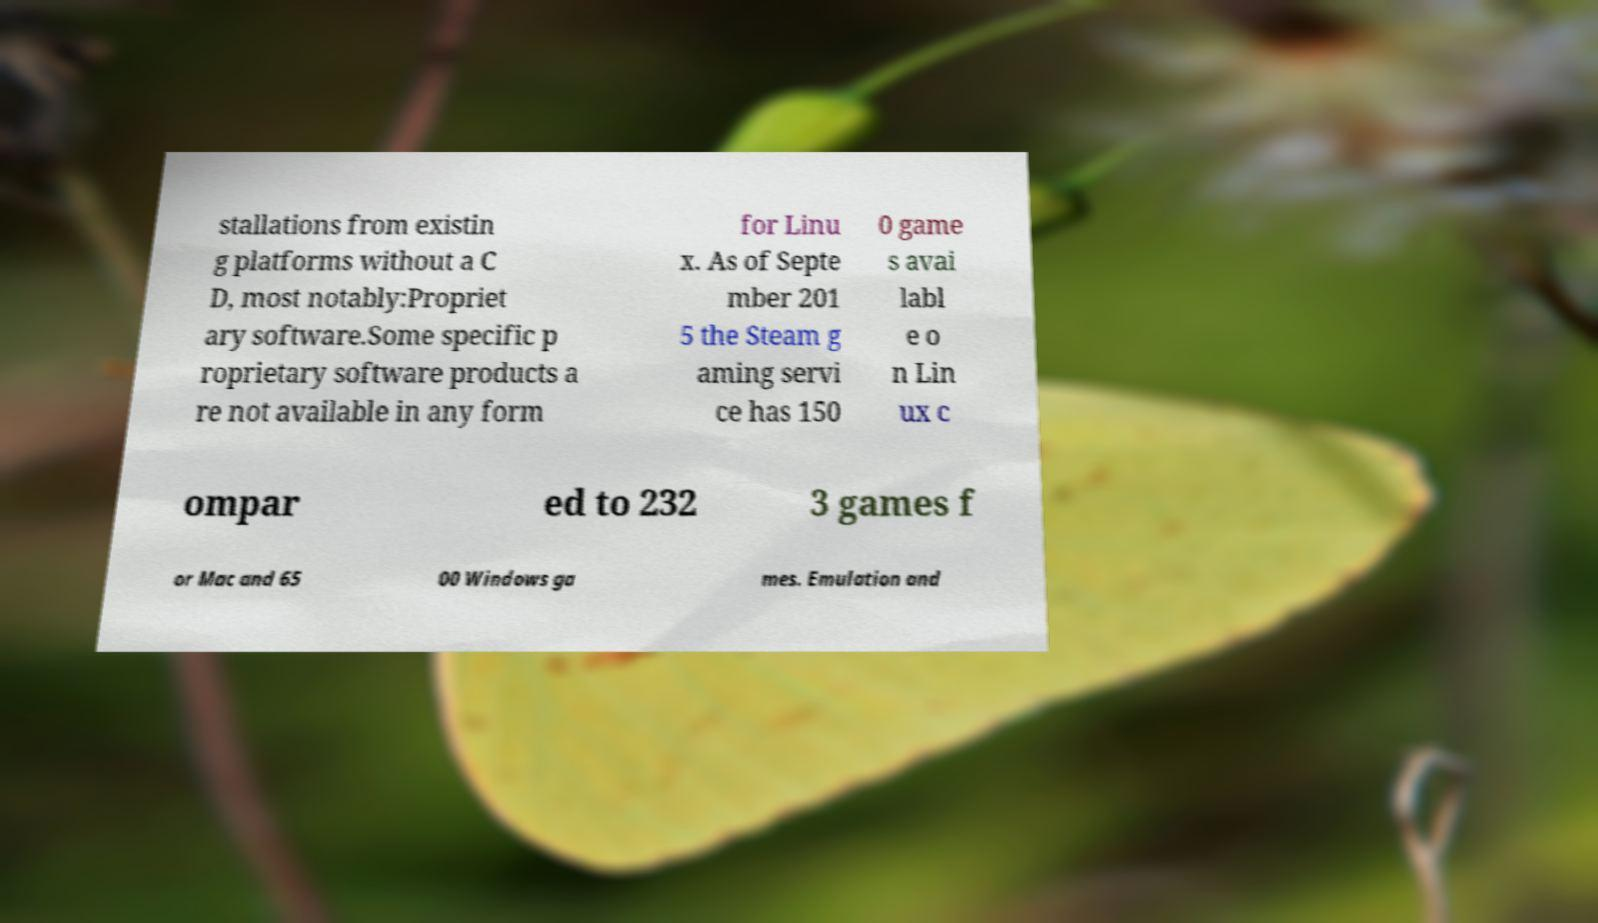Could you extract and type out the text from this image? stallations from existin g platforms without a C D, most notably:Propriet ary software.Some specific p roprietary software products a re not available in any form for Linu x. As of Septe mber 201 5 the Steam g aming servi ce has 150 0 game s avai labl e o n Lin ux c ompar ed to 232 3 games f or Mac and 65 00 Windows ga mes. Emulation and 